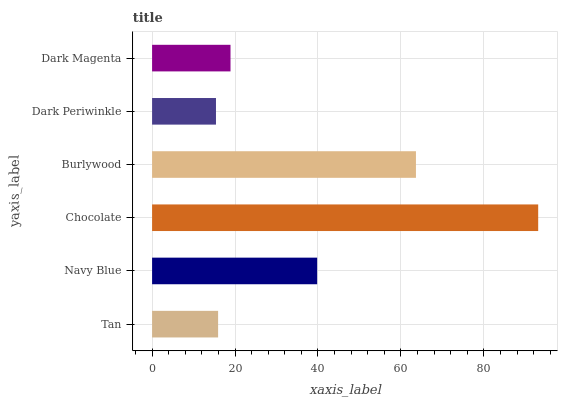Is Dark Periwinkle the minimum?
Answer yes or no. Yes. Is Chocolate the maximum?
Answer yes or no. Yes. Is Navy Blue the minimum?
Answer yes or no. No. Is Navy Blue the maximum?
Answer yes or no. No. Is Navy Blue greater than Tan?
Answer yes or no. Yes. Is Tan less than Navy Blue?
Answer yes or no. Yes. Is Tan greater than Navy Blue?
Answer yes or no. No. Is Navy Blue less than Tan?
Answer yes or no. No. Is Navy Blue the high median?
Answer yes or no. Yes. Is Dark Magenta the low median?
Answer yes or no. Yes. Is Burlywood the high median?
Answer yes or no. No. Is Dark Periwinkle the low median?
Answer yes or no. No. 